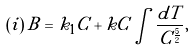<formula> <loc_0><loc_0><loc_500><loc_500>( i ) \, B = k _ { 1 } C + k C \int { \frac { d T } { C ^ { \frac { 5 } { 2 } } } } ,</formula> 